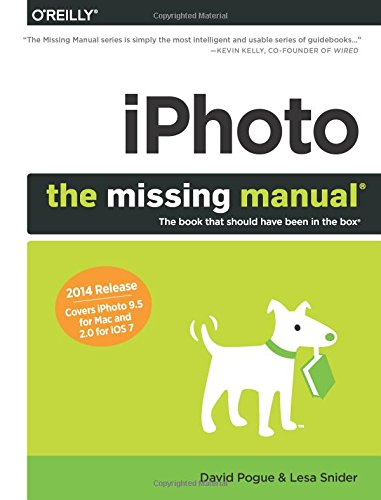Is this book related to Computers & Technology? Yes, absolutely. The book provides in-depth technical instructions and tips on how to use iPhoto, which is a software application developed by Apple, making it highly relevant to the field of technology. 